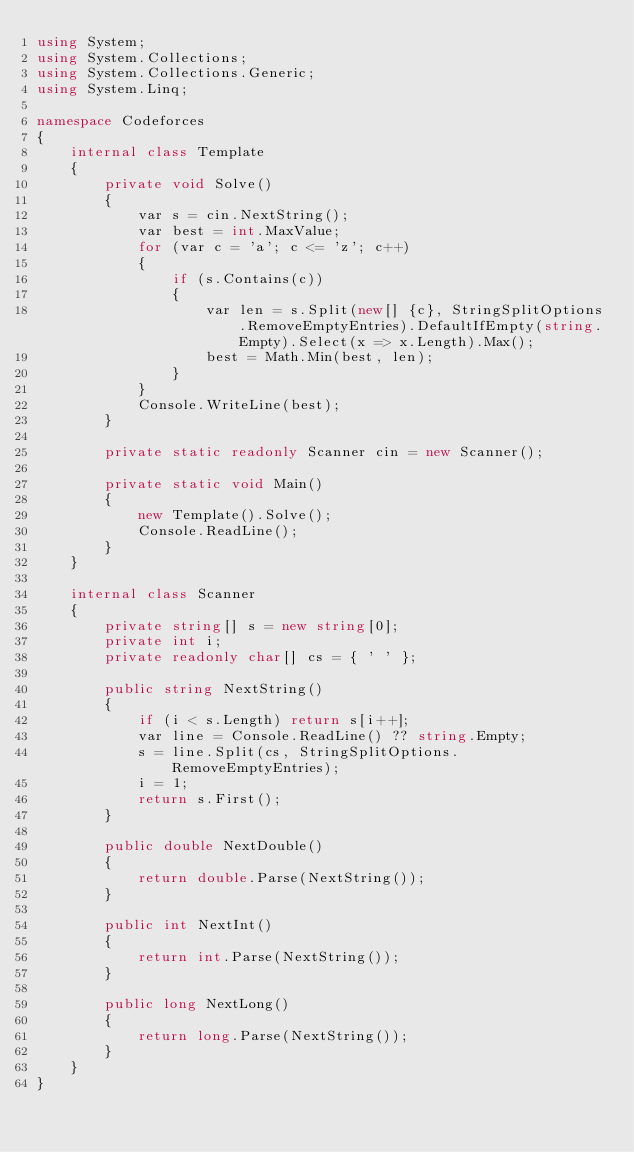<code> <loc_0><loc_0><loc_500><loc_500><_C#_>using System;
using System.Collections;
using System.Collections.Generic;
using System.Linq;

namespace Codeforces
{
	internal class Template
	{
		private void Solve()
		{
			var s = cin.NextString();
			var best = int.MaxValue;
			for (var c = 'a'; c <= 'z'; c++)
			{
				if (s.Contains(c))
				{
					var len = s.Split(new[] {c}, StringSplitOptions.RemoveEmptyEntries).DefaultIfEmpty(string.Empty).Select(x => x.Length).Max();
					best = Math.Min(best, len);
				}
			}
			Console.WriteLine(best);
		}

		private static readonly Scanner cin = new Scanner();

		private static void Main()
		{
			new Template().Solve();
			Console.ReadLine();
		}
	}

	internal class Scanner
	{
		private string[] s = new string[0];
		private int i;
		private readonly char[] cs = { ' ' };

		public string NextString()
		{
			if (i < s.Length) return s[i++];
			var line = Console.ReadLine() ?? string.Empty;
			s = line.Split(cs, StringSplitOptions.RemoveEmptyEntries);
			i = 1;
			return s.First();
		}

		public double NextDouble()
		{
			return double.Parse(NextString());
		}

		public int NextInt()
		{
			return int.Parse(NextString());
		}

		public long NextLong()
		{
			return long.Parse(NextString());
		}
	}
}</code> 